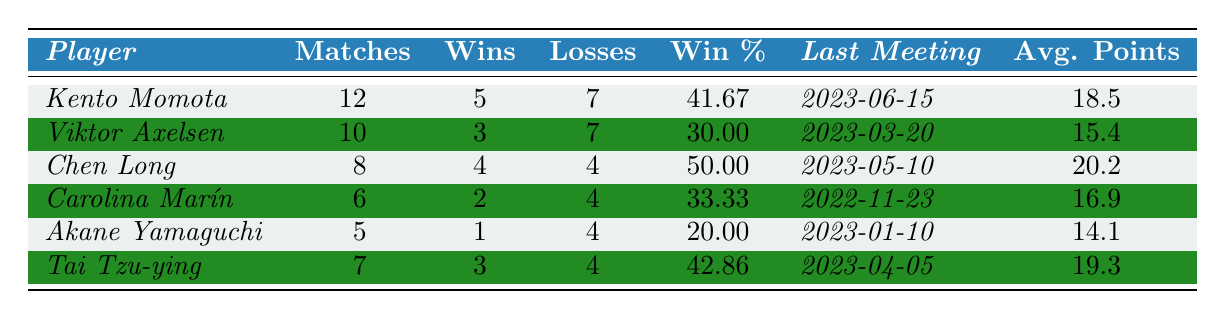What is the win percentage of Kento Momota? The table shows Kento Momota's win percentage directly listed as 41.67%.
Answer: 41.67% How many matches did Viktor Axelsen play? Viktor Axelsen's total matches played is indicated in the table as 10.
Answer: 10 Which player has the highest average points per match? Comparing the "Avg. Points" column, Chen Long has the highest average points of 20.2 per match.
Answer: Chen Long What is the total number of wins by Tai Tzu-ying and Chen Long combined? Tai Tzu-ying has 3 wins and Chen Long has 4 wins, so combined they have 3 + 4 = 7 wins.
Answer: 7 Did Akane Yamaguchi win more matches than Carolina Marín? Akane Yamaguchi has 1 win, while Carolina Marín has 2 wins. Since 1 is less than 2, the statement is false.
Answer: No Which player has the most losses? Kento Momota has 7 losses, which is the highest in the table when compared to all other players.
Answer: Kento Momota What is the average win percentage of all the players listed? The win percentages are 41.67, 30.00, 50.00, 33.33, 20.00, and 42.86. Summing these gives 41.67 + 30.00 + 50.00 + 33.33 + 20.00 + 42.86 = 218.86. Dividing by 6 (the number of players) gives the average of 218.86 / 6 = 36.48.
Answer: 36.48 Who was the last opponent Kento Momota played against? The last meeting date for Kento Momota is listed as 2023-06-15, but the table does not provide the opponent's name. Thus, I cannot determine who this was.
Answer: Not available How many players have a win percentage above 40%? Kento Momota (41.67%), Chen Long (50.00%), and Tai Tzu-ying (42.86%) all have win percentages above 40%. Therefore, there are 3 players that meet this criterion.
Answer: 3 What is the difference in wins between Chen Long and Akane Yamaguchi? Chen Long has 4 wins and Akane Yamaguchi has 1 win. The difference is 4 - 1 = 3.
Answer: 3 